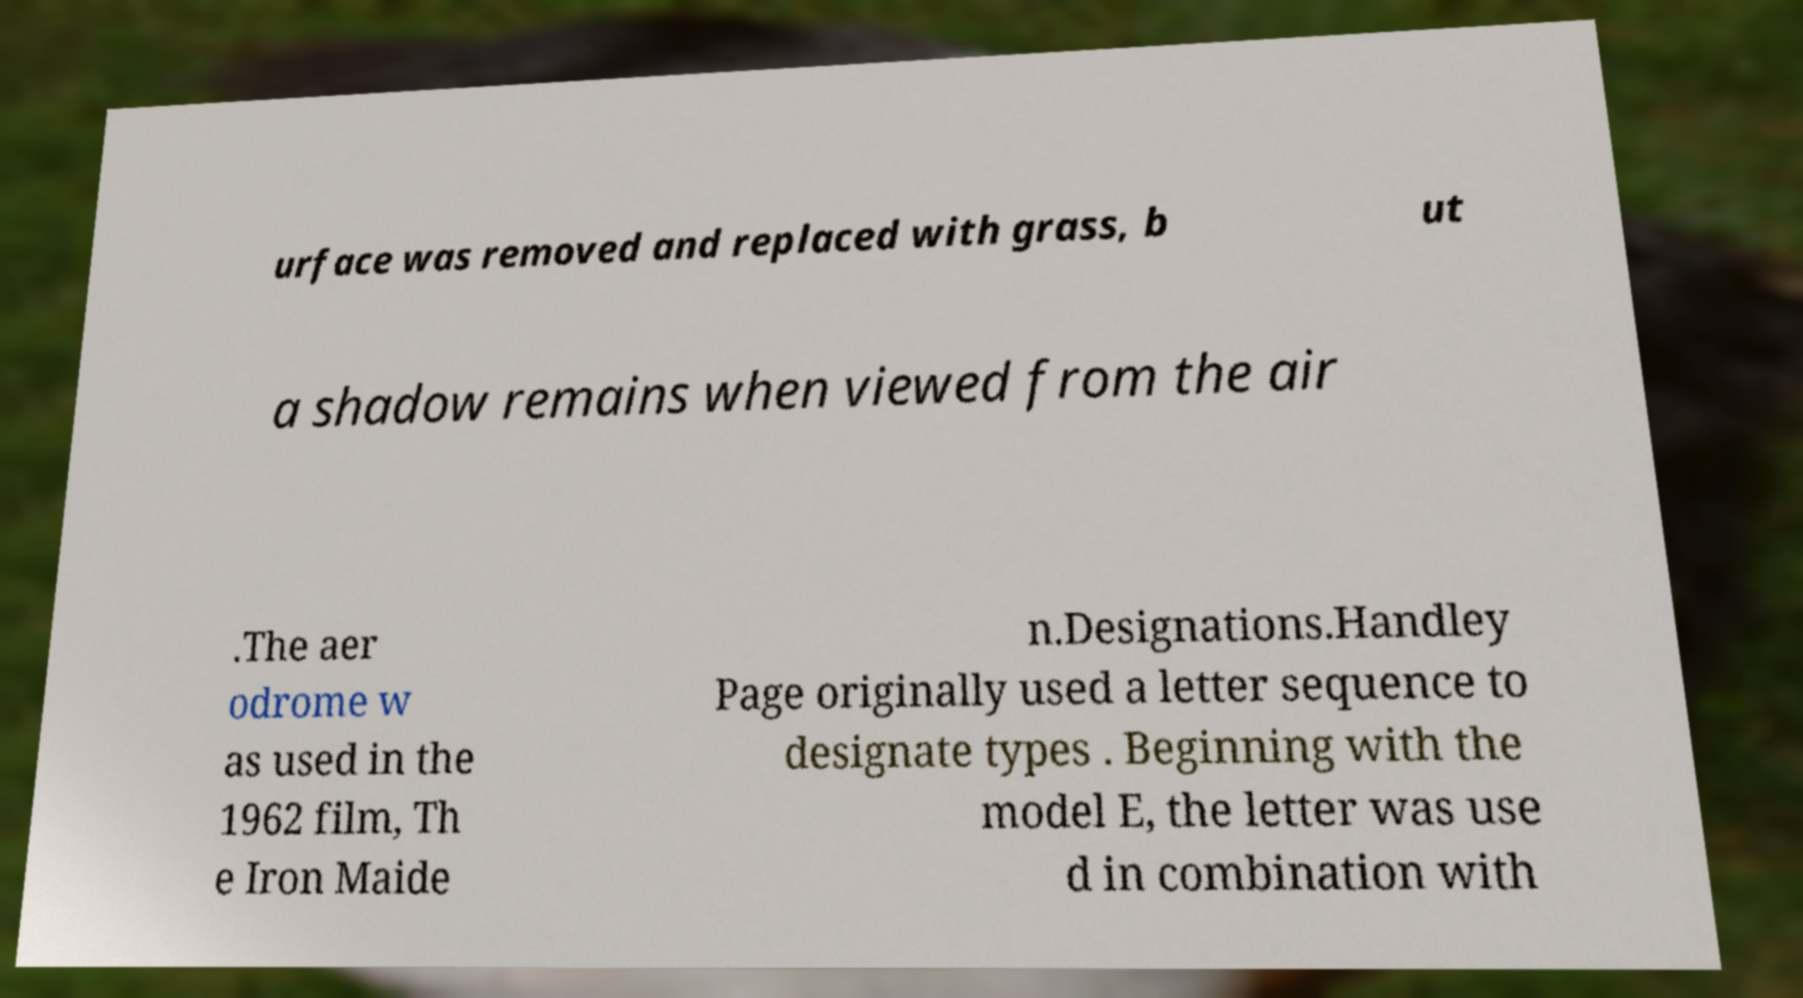I need the written content from this picture converted into text. Can you do that? urface was removed and replaced with grass, b ut a shadow remains when viewed from the air .The aer odrome w as used in the 1962 film, Th e Iron Maide n.Designations.Handley Page originally used a letter sequence to designate types . Beginning with the model E, the letter was use d in combination with 